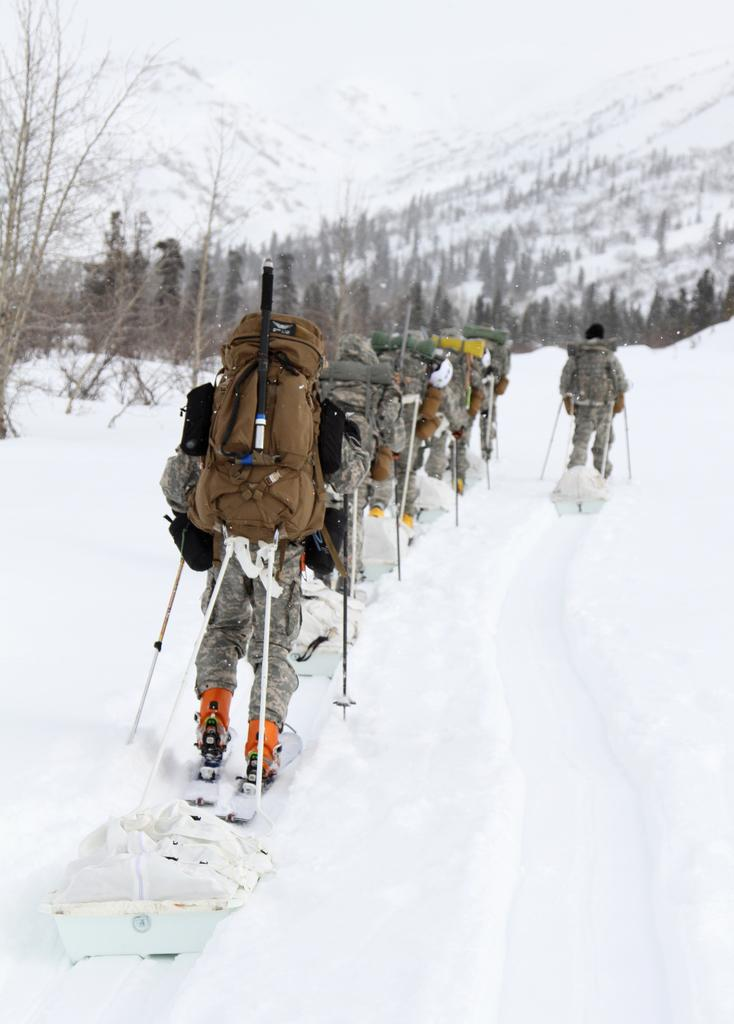What type of vegetation can be seen in the image? There are trees in the image. What is the weather like in the image? There is snow in the image, suggesting a cold or wintery environment. What are the people in the image doing? The people are wearing backpacks and holding ski sticks in their hands, which suggests they are skiing or preparing to ski. Can you tell me how many churches are visible in the image? There are no churches present in the image; it features trees, snow, and people with ski equipment. Does the existence of snow in the image imply that the people are skiing on a roof? There is no indication of a roof in the image, and the people are holding ski sticks, which suggests they are skiing on a snowy slope or terrain. 